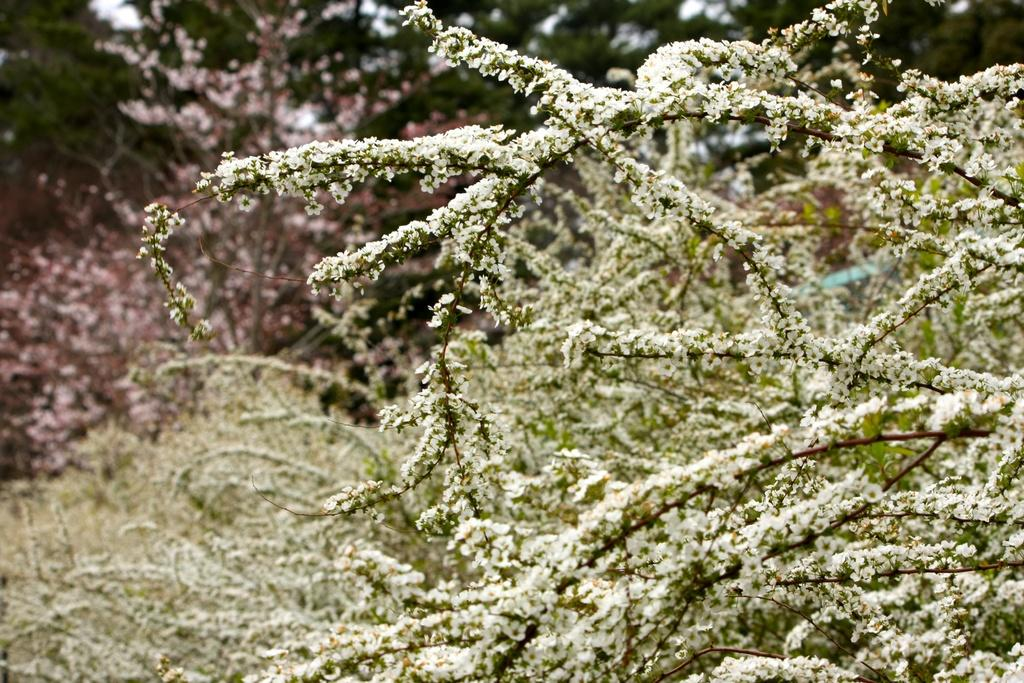What type of plants can be seen in the image? There are plants with tiny leaves in the image. What other vegetation is visible in the image? There are trees visible in the image. What is the color of the trees in the image? The trees are green in color. How many yams are hanging from the trees in the image? There are no yams present in the image; it features plants with tiny leaves and trees. Can you see any lizards crawling on the trees in the image? There are no lizards visible in the image; it only shows plants, trees, and their colors. 